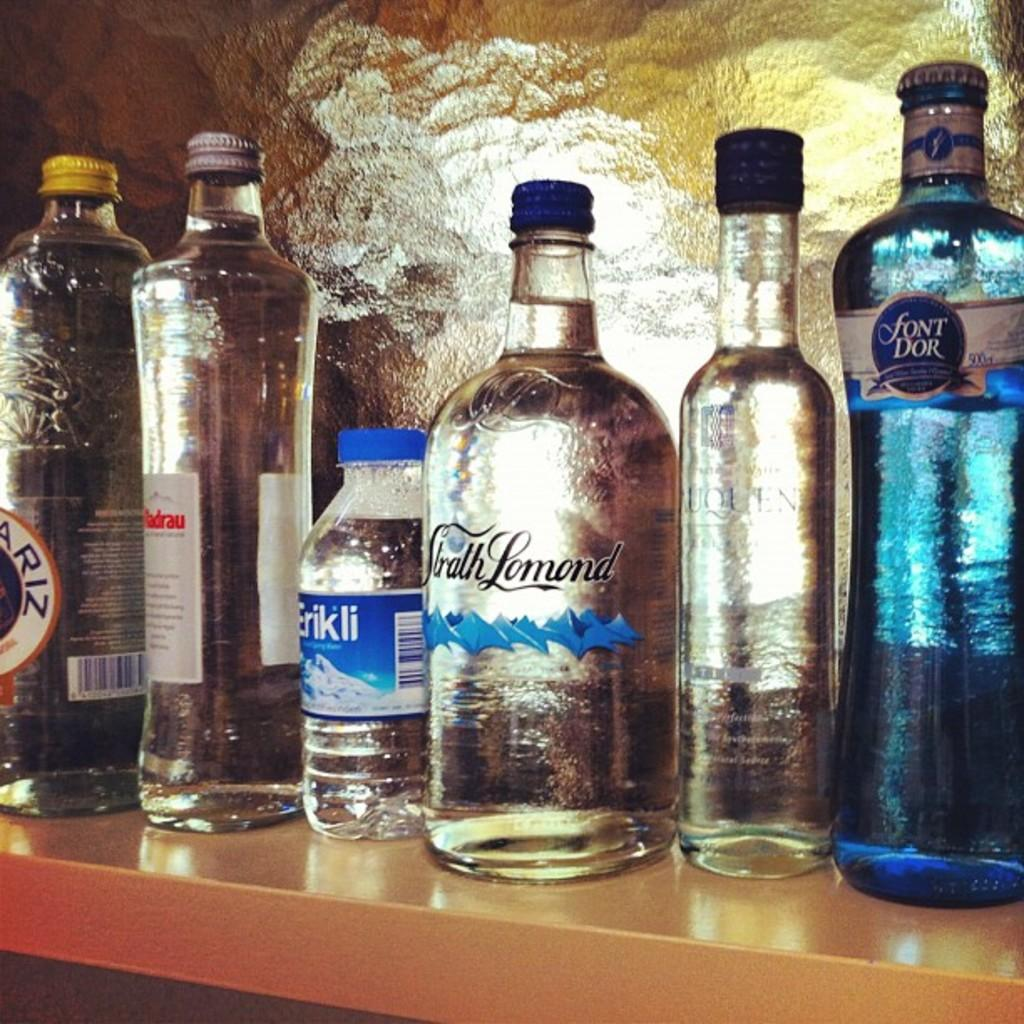<image>
Provide a brief description of the given image. Several bottles, one of which is blue and is called font dor 